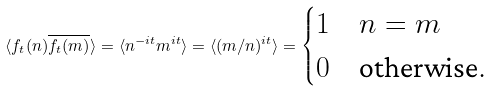<formula> <loc_0><loc_0><loc_500><loc_500>\langle f _ { t } ( n ) \overline { f _ { t } ( m ) } \rangle = \langle n ^ { - i t } m ^ { i t } \rangle = \langle ( m / n ) ^ { i t } \rangle = \begin{cases} 1 & n = m \\ 0 & \text {otherwise} . \end{cases}</formula> 